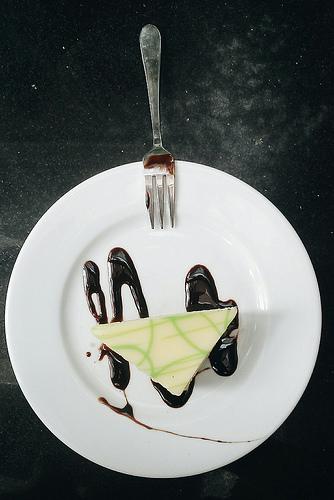<image>
Can you confirm if the food is on the plate? Yes. Looking at the image, I can see the food is positioned on top of the plate, with the plate providing support. Is there a fork above the plate? No. The fork is not positioned above the plate. The vertical arrangement shows a different relationship. 